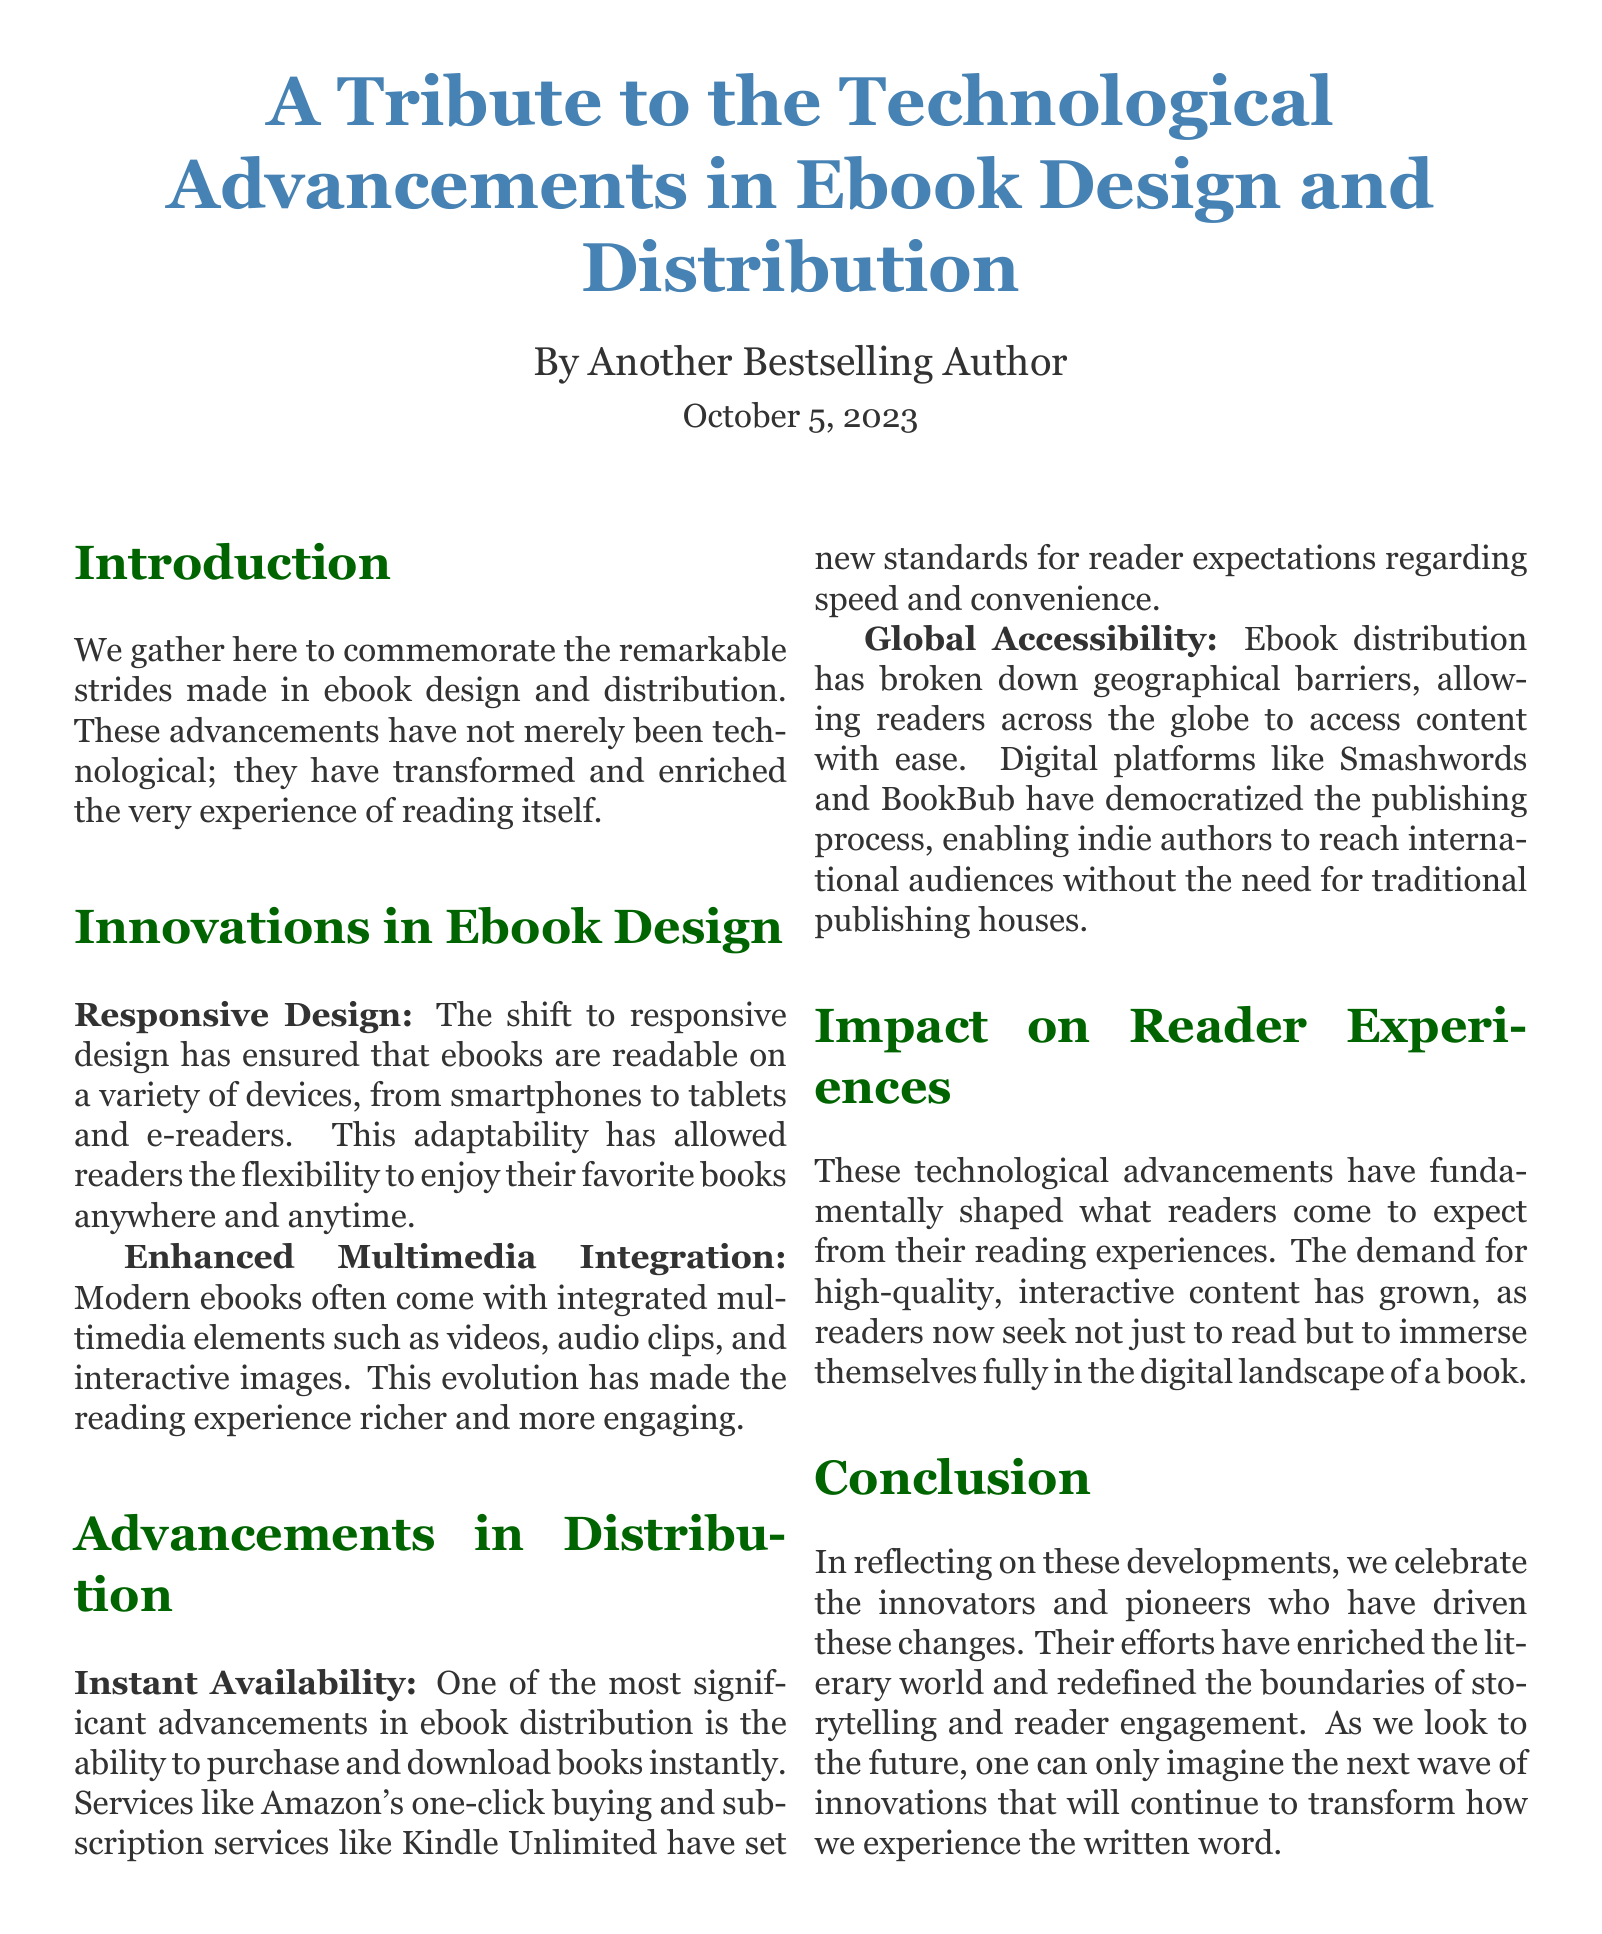What is the title of the document? The title is presented at the beginning of the document and reflects the main topic discussed within.
Answer: A Tribute to the Technological Advancements in Ebook Design and Distribution Who is the author of the document? The author is mentioned directly under the title in the introduction section.
Answer: Another Bestselling Author What date is mentioned in the document? The date is provided at the end of the title section, indicating when the document was created or published.
Answer: October 5, 2023 What is one key aspect of innovations in ebook design mentioned? The document lists specific innovations in ebook design, focusing on adaptability and engagement.
Answer: Responsive Design What advancement in distribution is highlighted for its significance? The document discusses several advancements, but one is emphasized for changing reader expectations.
Answer: Instant Availability Which element enhances reader engagement according to the document? The document refers to various multimedia features that contribute to a richer reading experience.
Answer: Enhanced Multimedia Integration What has ebook distribution broken down according to the text? The document mentions a specific barrier that ebook distribution has eliminated, which aids accessibility.
Answer: Geographical barriers What main impact do advancements have on reader expectations? The text concludes that such advancements have led to a significant change in how readers engage with ebooks.
Answer: High-quality, interactive content What does the conclusion encourage us to look toward? The concluding remarks suggest a forward-looking view regarding future developments in ebook technology.
Answer: Next wave of innovations 